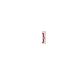<code> <loc_0><loc_0><loc_500><loc_500><_CSS_>}
</code> 